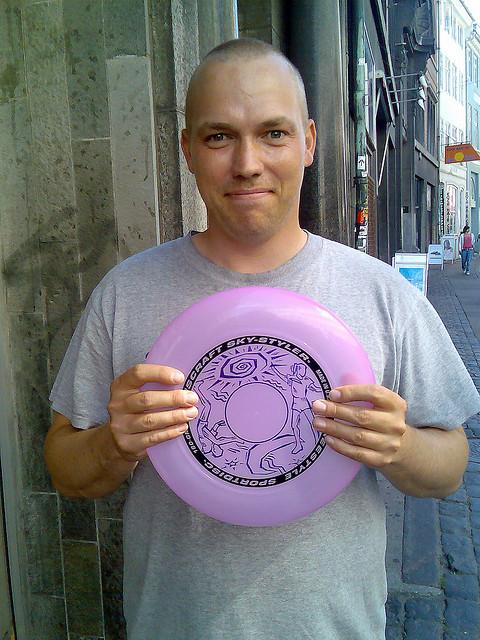This frisbee is how many grams?

Choices:
A) 200
B) 300
C) 160
D) 250 160 